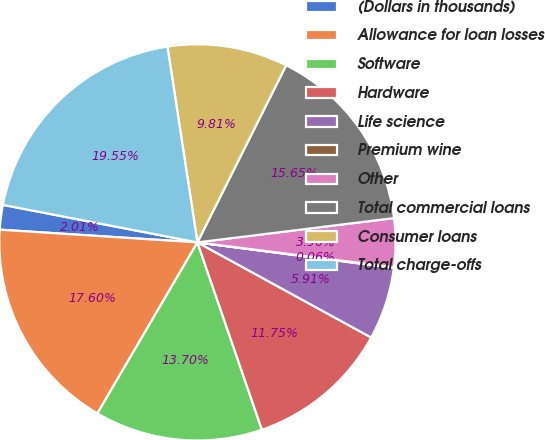Convert chart to OTSL. <chart><loc_0><loc_0><loc_500><loc_500><pie_chart><fcel>(Dollars in thousands)<fcel>Allowance for loan losses<fcel>Software<fcel>Hardware<fcel>Life science<fcel>Premium wine<fcel>Other<fcel>Total commercial loans<fcel>Consumer loans<fcel>Total charge-offs<nl><fcel>2.01%<fcel>17.6%<fcel>13.7%<fcel>11.75%<fcel>5.91%<fcel>0.06%<fcel>3.96%<fcel>15.65%<fcel>9.81%<fcel>19.55%<nl></chart> 